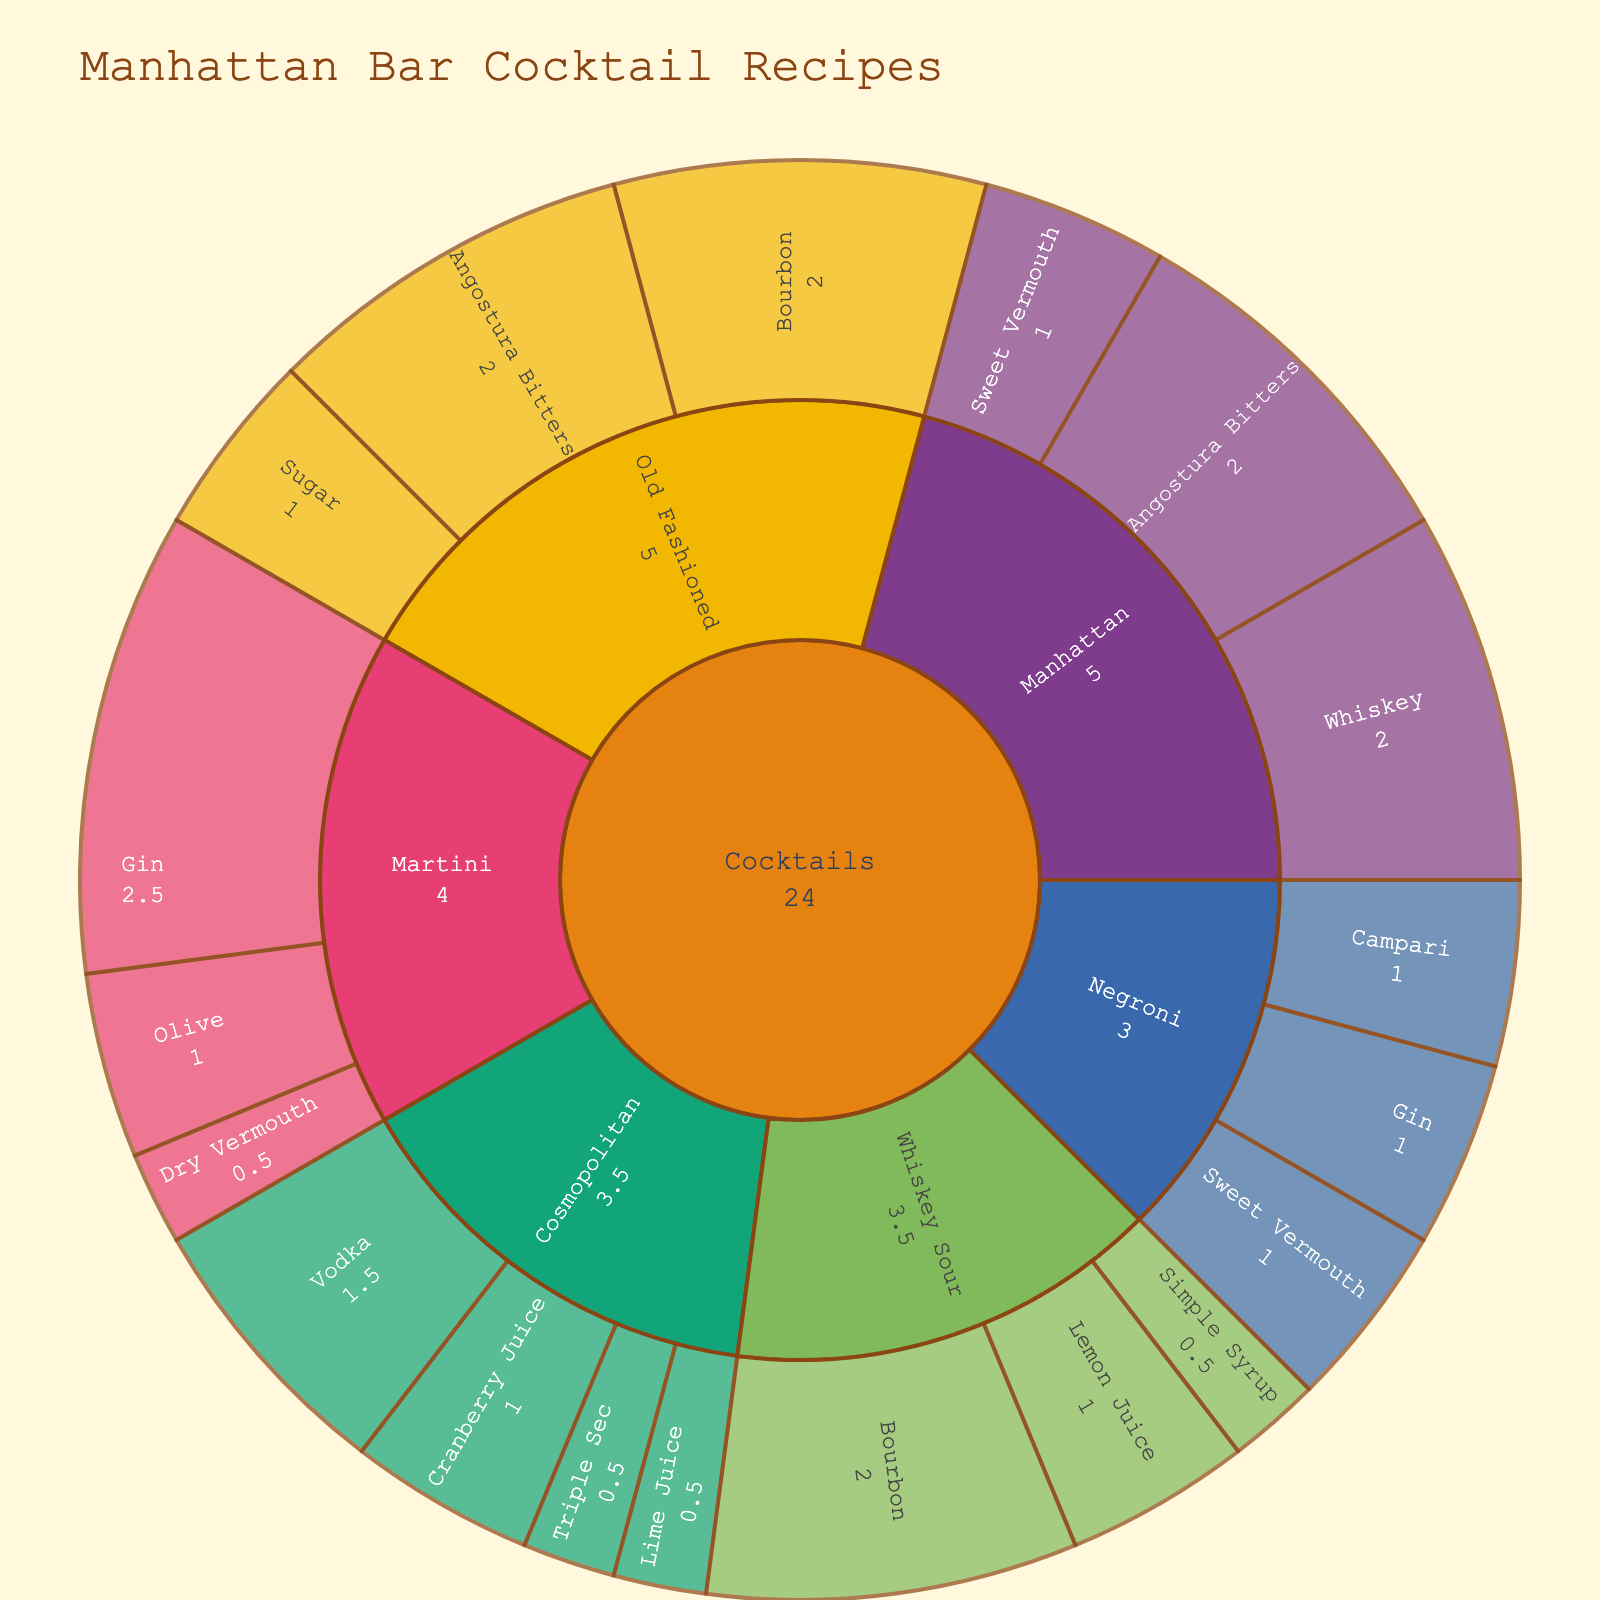What is the title of the sunburst plot? The title can be found at the top of the plot. It summarizes the main subject of the visualization.
Answer: Manhattan Bar Cocktail Recipes Which ingredients are used in the Manhattan cocktail, and how are they proportioned? Locate the 'Manhattan' subcategory under 'Cocktails'. Each ingredient and its proportion are shown within this section.
Answer: Whiskey: 2, Sweet Vermouth: 1, Angostura Bitters: 2 What is the total amount of Angostura Bitters used across all cocktails? Sum the values of Angostura Bitters found in both 'Manhattan' and 'Old Fashioned'.
Answer: 4 Compare the amount of Gin in a Martini and a Negroni. Which one uses more, and by how much? Observe under 'Martini' and 'Negroni' subcategories; Martini uses 2.5 units of Gin and Negroni uses 1 unit of Gin.
Answer: Martini uses 1.5 more units of Gin than Negroni Which cocktail has the highest total value of ingredients, and what is the total? Sum the ingredient values for each cocktail subcategory, and compare. Manhattan: 2+1+2=5, Old Fashioned: 2+1+2=5, Martini: 2.5+0.5+1=4, Negroni: 1+1+1=3, Whiskey Sour: 2+1+0.5=3.5, Cosmopolitan: 1.5+1+0.5+0.5=3.5. Both Manhattan and Old Fashioned have the highest total.
Answer: Manhattan and Old Fashioned with 5 units each What is the average amount of Whiskey and Bourbon used per cocktail that includes them? Identify the cocktails with Whiskey and Bourbon: Manhattan (Whiskey: 2), Old Fashioned (Bourbon: 2), Whiskey Sour (Bourbon: 2). Calculate the average: (2+2+2) / 3 = 2.
Answer: 2 Which ingredient appears the most frequently across all cocktails? Count how many times each ingredient appears in the subcategories. Angostura Bitters appear twice (in Old Fashioned and Manhattan).
Answer: Angostura Bitters What are the ingredients and their proportions for the Negroni cocktail? Locate the 'Negroni' subcategory under 'Cocktails'. Each ingredient and its proportion are shown within this section.
Answer: Gin: 1, Campari: 1, Sweet Vermouth: 1 How many cocktails include Vermouth (Sweet or Dry)? Identify cocktails containing Vermouth by checking 'Sweet Vermouth' and 'Dry Vermouth' across the subcategories: Manhattan, Negroni (Sweet Vermouth), Martini (Dry Vermouth).
Answer: 3 cocktails Among the cocktails listed, which one does not contain any type of whiskey or bourbon? Identify cocktails without ingredients labeled as Whiskey or Bourbon by checking each subcategory: Negroni, Martini, and Cosmopolitan do not contain whiskey or bourbon.
Answer: Negroni, Martini, and Cosmopolitan 